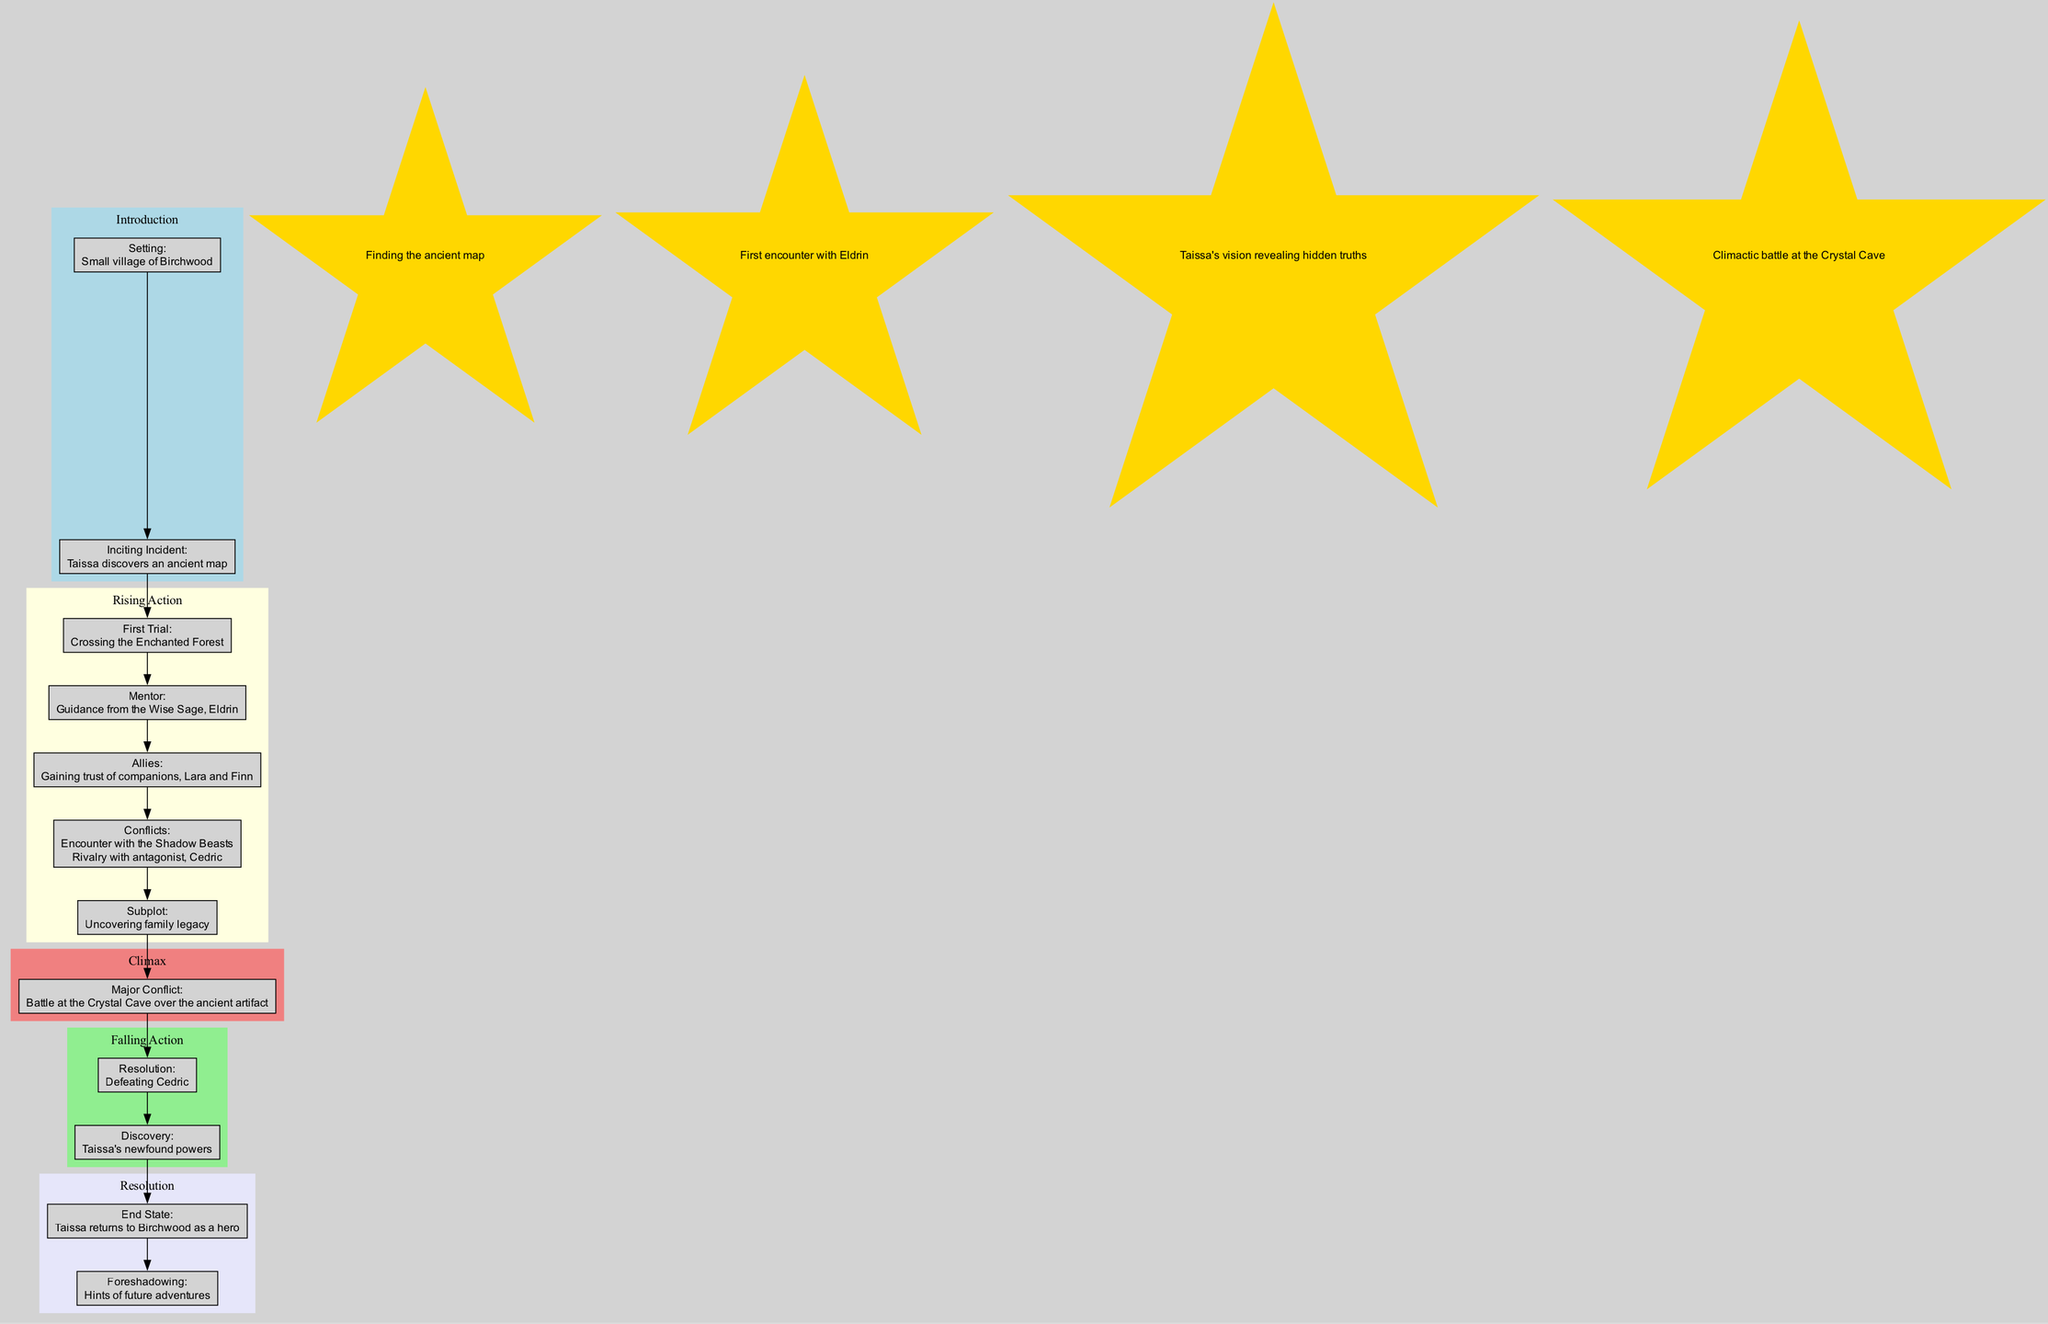What is the setting of Taissa's journey? The diagram indicates that the setting is a "Small village of Birchwood," which can be found in the "Introduction" section.
Answer: Small village of Birchwood Who guides Taissa during her journey? The "Mentor" node in the diagram specifies "Guidance from the Wise Sage, Eldrin," which highlights who is mentoring Taissa.
Answer: Eldrin What is the major conflict in Taissa's journey? Located in the "Climax" section, the diagram notes that the major conflict is a "Battle at the Crystal Cave over the ancient artifact," which represents the peak of tension in the plot.
Answer: Battle at the Crystal Cave over the ancient artifact How many pivotal moments are highlighted in the diagram? By counting the number of items in the "Pivotal Moments" list, there are four distinct pivotal moments indicated, leading to significant changes in the storyline.
Answer: 4 What does Taissa discover in the falling action? Within the "Falling Action" section, the diagram indicates that Taissa discovers her "newfound powers," which reflects her character's development and growth.
Answer: Taissa's newfound powers What connects the "Subplot" to the "Major Conflict"? The diagram shows a direct edge connecting the "Subplot" node to the "Major Conflict" node, illustrating the role the subplot plays in leading to the climax in the journey.
Answer: Edge connection What hints at potential future adventures for Taissa? According to the diagram, the "Foreshadowing" node within the "Resolution" section suggests hints of future adventures for Taissa, hinting at ongoing development after the story's conclusion.
Answer: Hints of future adventures Which character has a rivalry with Taissa? The diagram lists "Rivalry with antagonist, Cedric" as one of the conflicts in the "Rising Action" section, indicating that Cedric is a significant rival in Taissa's journey.
Answer: Cedric How does the story conclude for Taissa? The "End State" in the "Resolution" section states that "Taissa returns to Birchwood as a hero," summarizing the outcome of her journey and character arc.
Answer: Taissa returns to Birchwood as a hero 